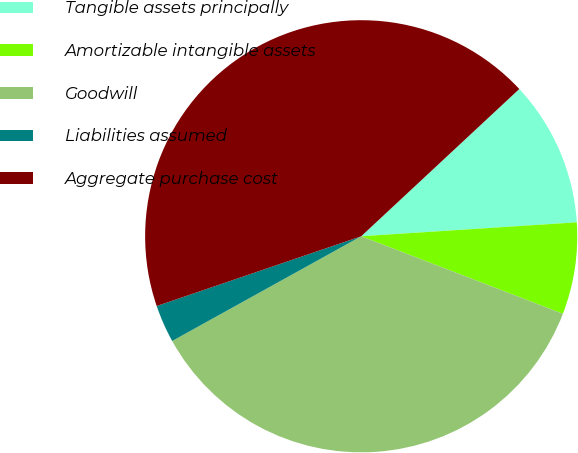<chart> <loc_0><loc_0><loc_500><loc_500><pie_chart><fcel>Tangible assets principally<fcel>Amortizable intangible assets<fcel>Goodwill<fcel>Liabilities assumed<fcel>Aggregate purchase cost<nl><fcel>10.91%<fcel>6.87%<fcel>36.11%<fcel>2.82%<fcel>43.3%<nl></chart> 